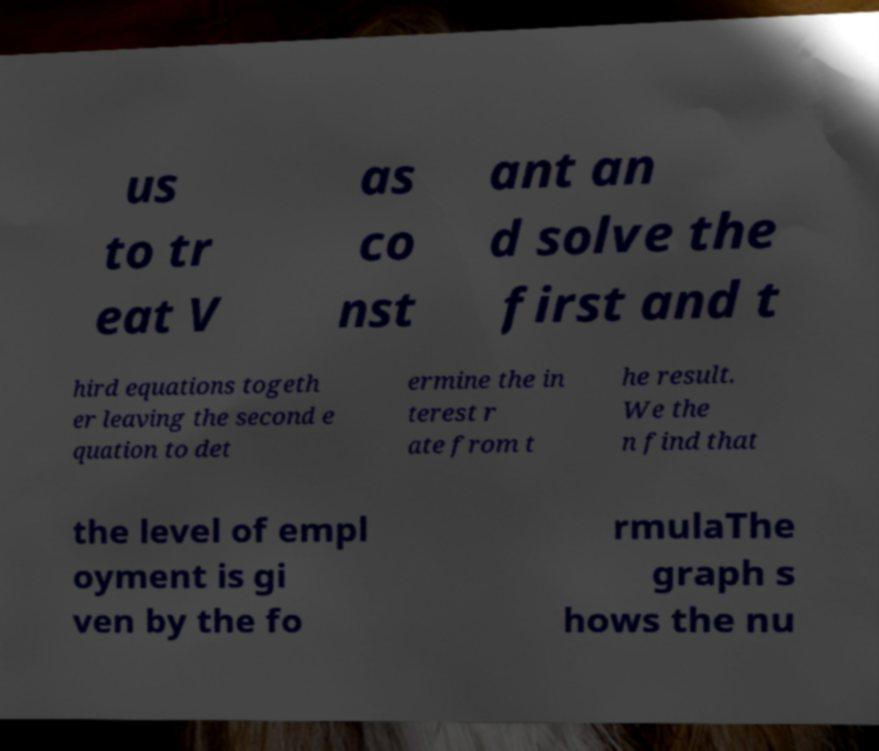Can you read and provide the text displayed in the image?This photo seems to have some interesting text. Can you extract and type it out for me? us to tr eat V as co nst ant an d solve the first and t hird equations togeth er leaving the second e quation to det ermine the in terest r ate from t he result. We the n find that the level of empl oyment is gi ven by the fo rmulaThe graph s hows the nu 